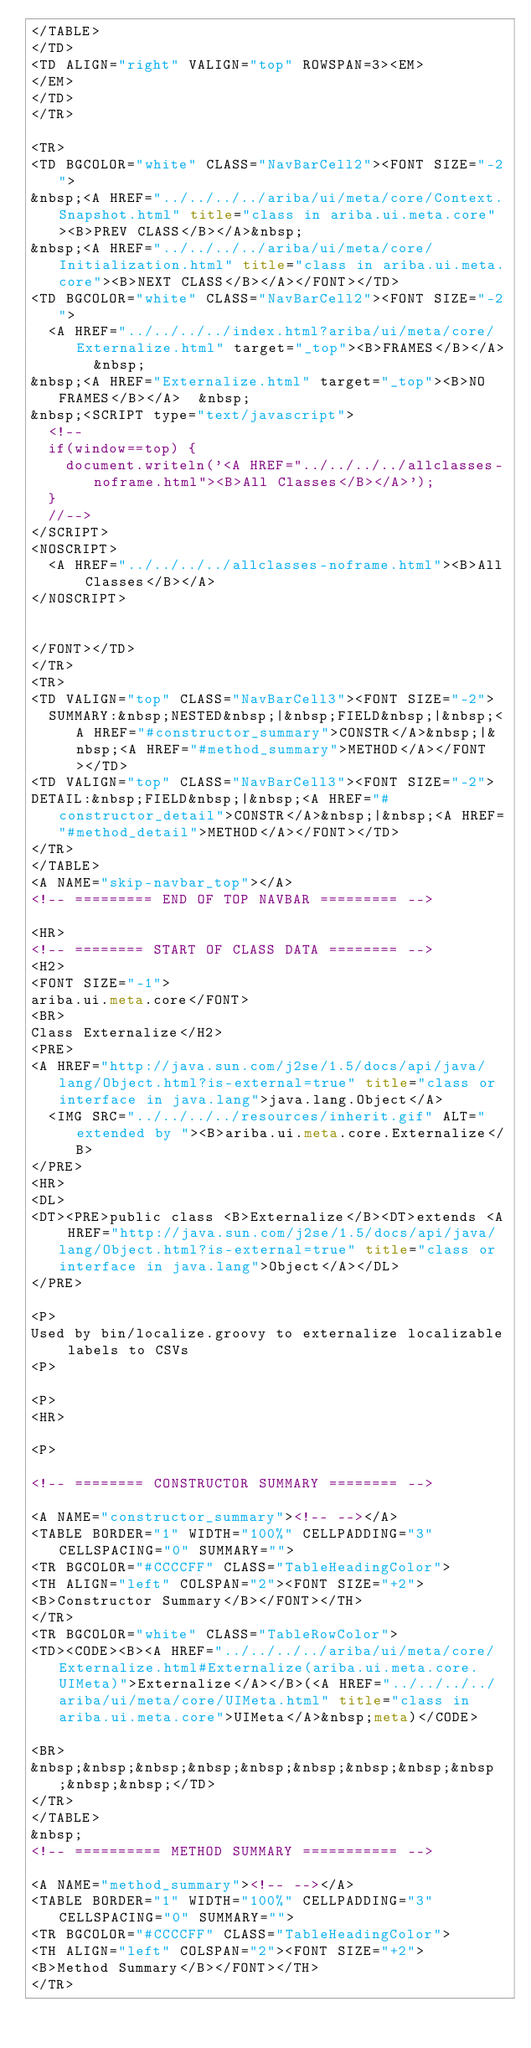<code> <loc_0><loc_0><loc_500><loc_500><_HTML_></TABLE>
</TD>
<TD ALIGN="right" VALIGN="top" ROWSPAN=3><EM>
</EM>
</TD>
</TR>

<TR>
<TD BGCOLOR="white" CLASS="NavBarCell2"><FONT SIZE="-2">
&nbsp;<A HREF="../../../../ariba/ui/meta/core/Context.Snapshot.html" title="class in ariba.ui.meta.core"><B>PREV CLASS</B></A>&nbsp;
&nbsp;<A HREF="../../../../ariba/ui/meta/core/Initialization.html" title="class in ariba.ui.meta.core"><B>NEXT CLASS</B></A></FONT></TD>
<TD BGCOLOR="white" CLASS="NavBarCell2"><FONT SIZE="-2">
  <A HREF="../../../../index.html?ariba/ui/meta/core/Externalize.html" target="_top"><B>FRAMES</B></A>  &nbsp;
&nbsp;<A HREF="Externalize.html" target="_top"><B>NO FRAMES</B></A>  &nbsp;
&nbsp;<SCRIPT type="text/javascript">
  <!--
  if(window==top) {
    document.writeln('<A HREF="../../../../allclasses-noframe.html"><B>All Classes</B></A>');
  }
  //-->
</SCRIPT>
<NOSCRIPT>
  <A HREF="../../../../allclasses-noframe.html"><B>All Classes</B></A>
</NOSCRIPT>


</FONT></TD>
</TR>
<TR>
<TD VALIGN="top" CLASS="NavBarCell3"><FONT SIZE="-2">
  SUMMARY:&nbsp;NESTED&nbsp;|&nbsp;FIELD&nbsp;|&nbsp;<A HREF="#constructor_summary">CONSTR</A>&nbsp;|&nbsp;<A HREF="#method_summary">METHOD</A></FONT></TD>
<TD VALIGN="top" CLASS="NavBarCell3"><FONT SIZE="-2">
DETAIL:&nbsp;FIELD&nbsp;|&nbsp;<A HREF="#constructor_detail">CONSTR</A>&nbsp;|&nbsp;<A HREF="#method_detail">METHOD</A></FONT></TD>
</TR>
</TABLE>
<A NAME="skip-navbar_top"></A>
<!-- ========= END OF TOP NAVBAR ========= -->

<HR>
<!-- ======== START OF CLASS DATA ======== -->
<H2>
<FONT SIZE="-1">
ariba.ui.meta.core</FONT>
<BR>
Class Externalize</H2>
<PRE>
<A HREF="http://java.sun.com/j2se/1.5/docs/api/java/lang/Object.html?is-external=true" title="class or interface in java.lang">java.lang.Object</A>
  <IMG SRC="../../../../resources/inherit.gif" ALT="extended by "><B>ariba.ui.meta.core.Externalize</B>
</PRE>
<HR>
<DL>
<DT><PRE>public class <B>Externalize</B><DT>extends <A HREF="http://java.sun.com/j2se/1.5/docs/api/java/lang/Object.html?is-external=true" title="class or interface in java.lang">Object</A></DL>
</PRE>

<P>
Used by bin/localize.groovy to externalize localizable labels to CSVs
<P>

<P>
<HR>

<P>

<!-- ======== CONSTRUCTOR SUMMARY ======== -->

<A NAME="constructor_summary"><!-- --></A>
<TABLE BORDER="1" WIDTH="100%" CELLPADDING="3" CELLSPACING="0" SUMMARY="">
<TR BGCOLOR="#CCCCFF" CLASS="TableHeadingColor">
<TH ALIGN="left" COLSPAN="2"><FONT SIZE="+2">
<B>Constructor Summary</B></FONT></TH>
</TR>
<TR BGCOLOR="white" CLASS="TableRowColor">
<TD><CODE><B><A HREF="../../../../ariba/ui/meta/core/Externalize.html#Externalize(ariba.ui.meta.core.UIMeta)">Externalize</A></B>(<A HREF="../../../../ariba/ui/meta/core/UIMeta.html" title="class in ariba.ui.meta.core">UIMeta</A>&nbsp;meta)</CODE>

<BR>
&nbsp;&nbsp;&nbsp;&nbsp;&nbsp;&nbsp;&nbsp;&nbsp;&nbsp;&nbsp;&nbsp;</TD>
</TR>
</TABLE>
&nbsp;
<!-- ========== METHOD SUMMARY =========== -->

<A NAME="method_summary"><!-- --></A>
<TABLE BORDER="1" WIDTH="100%" CELLPADDING="3" CELLSPACING="0" SUMMARY="">
<TR BGCOLOR="#CCCCFF" CLASS="TableHeadingColor">
<TH ALIGN="left" COLSPAN="2"><FONT SIZE="+2">
<B>Method Summary</B></FONT></TH>
</TR></code> 